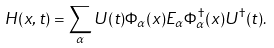<formula> <loc_0><loc_0><loc_500><loc_500>H ( x , t ) = \sum _ { \alpha } U ( t ) \Phi _ { \alpha } ( x ) E _ { \alpha } \Phi _ { \alpha } ^ { \dag } ( x ) U ^ { \dag } ( t ) .</formula> 